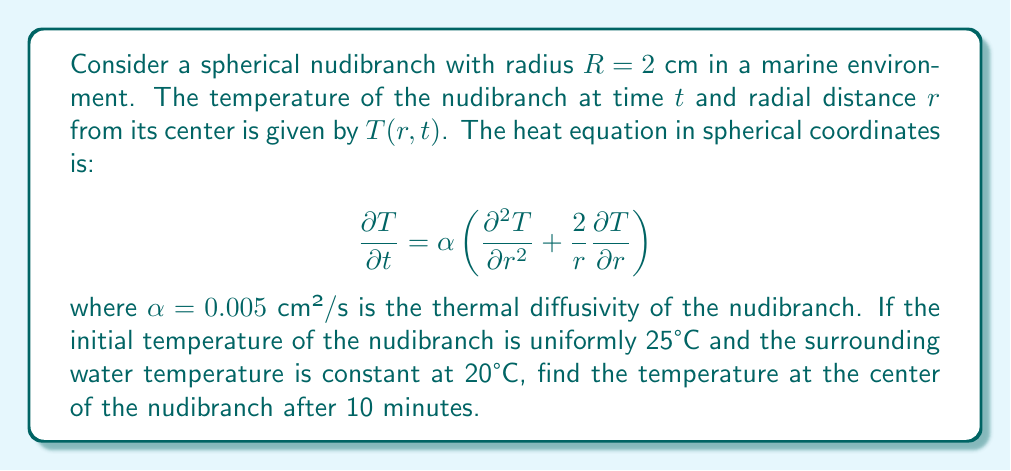Give your solution to this math problem. To solve this problem, we need to use the heat equation in spherical coordinates and apply the appropriate initial and boundary conditions. Let's approach this step-by-step:

1) Initial condition: $T(r,0) = 25°C$ for $0 \leq r \leq R$

2) Boundary condition: $T(R,t) = 20°C$ for $t > 0$

3) The solution to this problem can be expressed as a series:

   $$T(r,t) = 20 + \sum_{n=1}^{\infty} A_n \frac{\sin(n\pi r/R)}{r} e^{-\alpha n^2\pi^2t/R^2}$$

4) The coefficients $A_n$ can be found using the initial condition:

   $$A_n = \frac{2R}{n\pi} \int_0^R r \sin\left(\frac{n\pi r}{R}\right) (25-20) dr = \frac{10R^2(-1)^{n+1}}{n\pi}$$

5) At the center of the nudibranch, $r=0$. Using L'Hôpital's rule:

   $$\lim_{r\to 0} \frac{\sin(n\pi r/R)}{r} = \frac{n\pi}{R}$$

6) Therefore, at the center:

   $$T(0,t) = 20 + \sum_{n=1}^{\infty} \frac{10R(-1)^{n+1}}{n\pi} \cdot \frac{n\pi}{R} e^{-\alpha n^2\pi^2t/R^2}$$

   $$= 20 + 10\sum_{n=1}^{\infty} (-1)^{n+1} e^{-\alpha n^2\pi^2t/R^2}$$

7) After 10 minutes, $t = 600$ s. Substituting the values:

   $$T(0,600) = 20 + 10\sum_{n=1}^{\infty} (-1)^{n+1} e^{-0.005 \cdot n^2\pi^2 \cdot 600 / (0.02)^2}$$

8) Evaluating this series numerically (as it converges quickly), we get:

   $$T(0,600) \approx 20.0000678°C$$
Answer: 20.0000678°C 